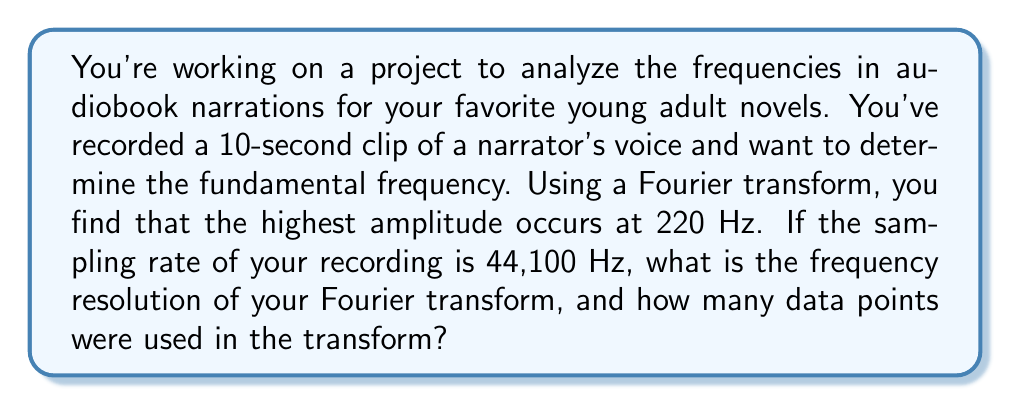Solve this math problem. Let's approach this step-by-step:

1) First, we need to understand what frequency resolution means. In a Fourier transform, the frequency resolution $\Delta f$ is given by:

   $$\Delta f = \frac{f_s}{N}$$

   Where $f_s$ is the sampling rate and $N$ is the number of data points.

2) We're given that the sampling rate $f_s = 44,100$ Hz.

3) To find $N$, we need to consider the length of the audio clip. We're told it's 10 seconds long. The number of data points is the sampling rate multiplied by the duration:

   $$N = f_s \times t = 44,100 \times 10 = 441,000$$

4) Now we can calculate the frequency resolution:

   $$\Delta f = \frac{f_s}{N} = \frac{44,100}{441,000} = 0.1 \text{ Hz}$$

This means our Fourier transform can distinguish between frequencies that are 0.1 Hz apart.

5) To double-check our work, we can use the relationship between time duration and frequency resolution:

   $$\Delta f = \frac{1}{T}$$

   Where $T$ is the total time of the signal. In our case, $T = 10$ seconds, so:

   $$\Delta f = \frac{1}{10} = 0.1 \text{ Hz}$$

   This confirms our calculation.
Answer: The frequency resolution is 0.1 Hz, and 441,000 data points were used in the Fourier transform. 